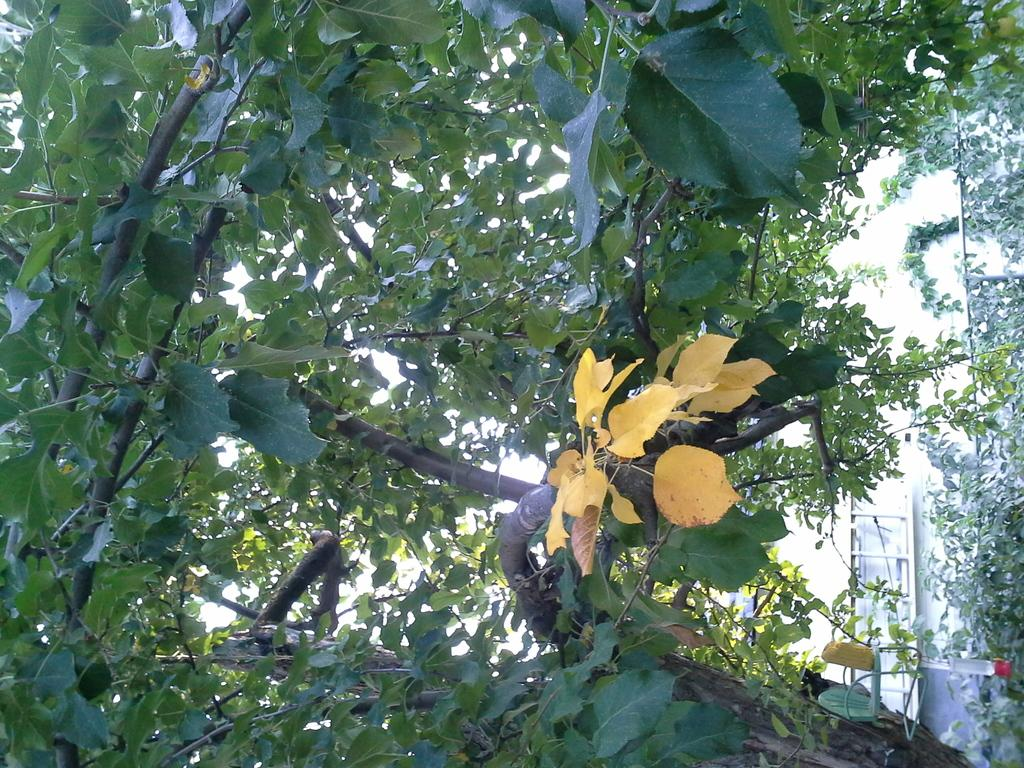What colors of leaves can be seen on the tree in the image? There are yellow and green color leaves on the tree in the image. Can you describe the background of the image? There is a ladder visible in the background of the image. How many dimes are scattered on the ground in the image? There are no dimes present in the image. Is the person's brother visible in the image? There is no person or brother mentioned in the provided facts, so we cannot determine their presence in the image. 